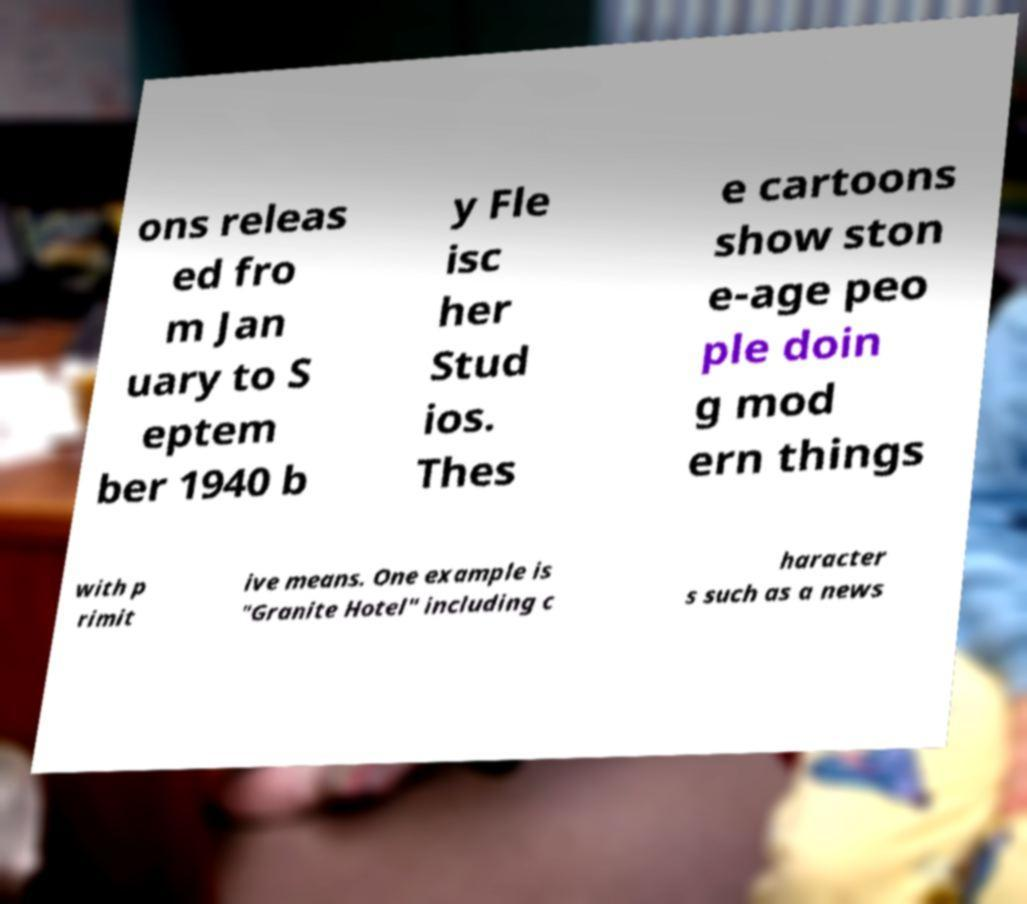There's text embedded in this image that I need extracted. Can you transcribe it verbatim? ons releas ed fro m Jan uary to S eptem ber 1940 b y Fle isc her Stud ios. Thes e cartoons show ston e-age peo ple doin g mod ern things with p rimit ive means. One example is "Granite Hotel" including c haracter s such as a news 